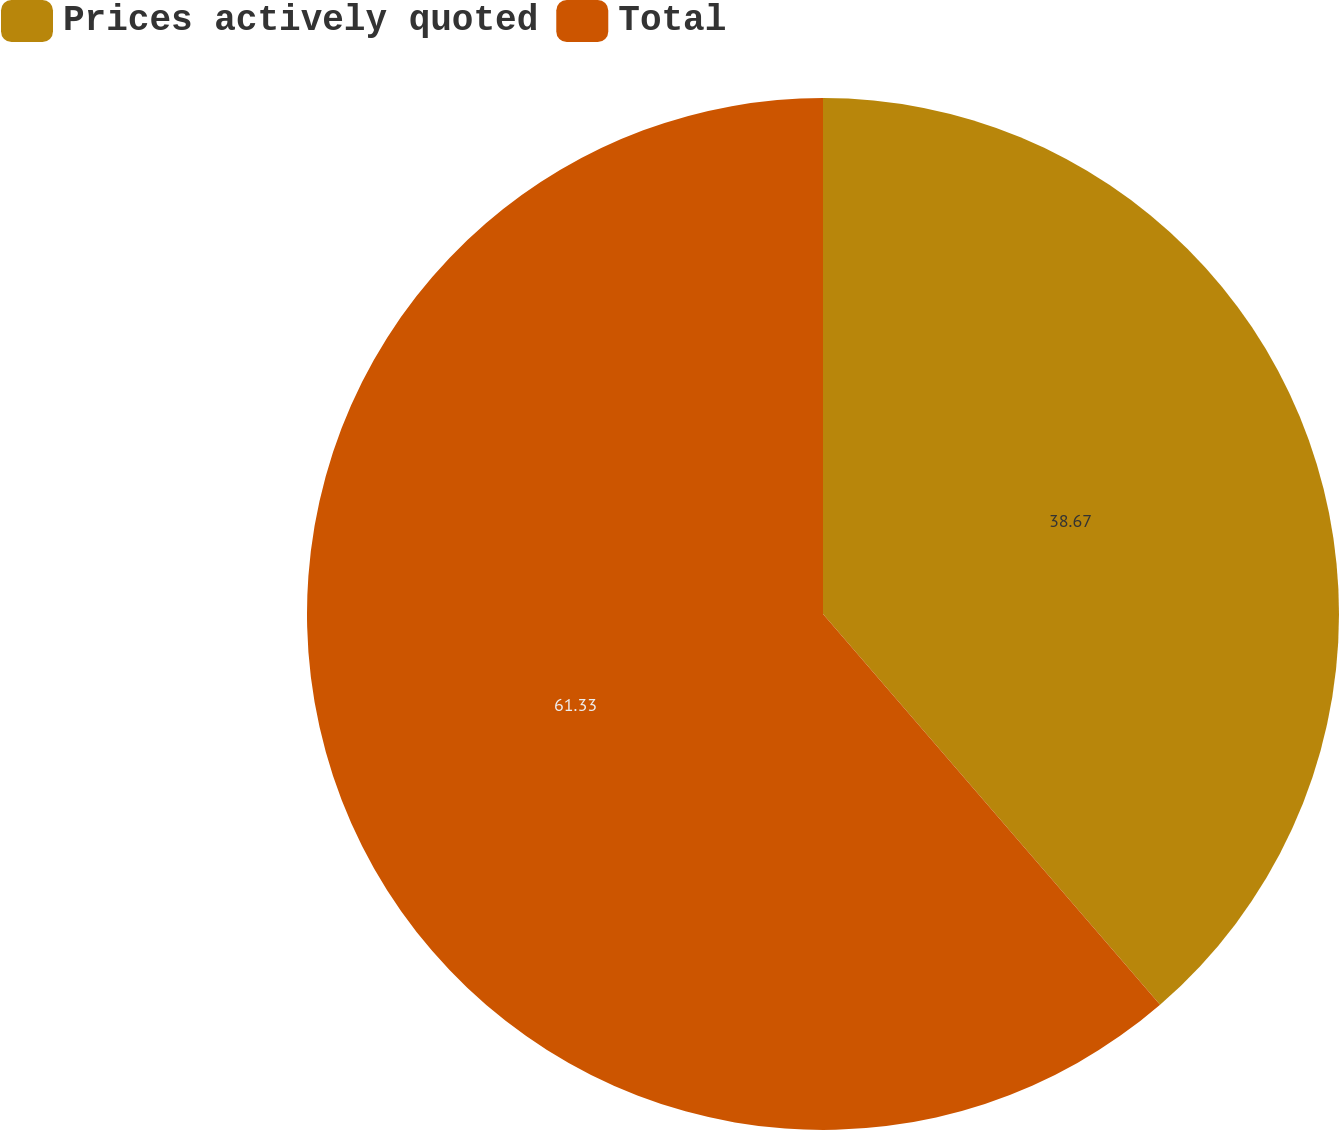Convert chart to OTSL. <chart><loc_0><loc_0><loc_500><loc_500><pie_chart><fcel>Prices actively quoted<fcel>Total<nl><fcel>38.67%<fcel>61.33%<nl></chart> 